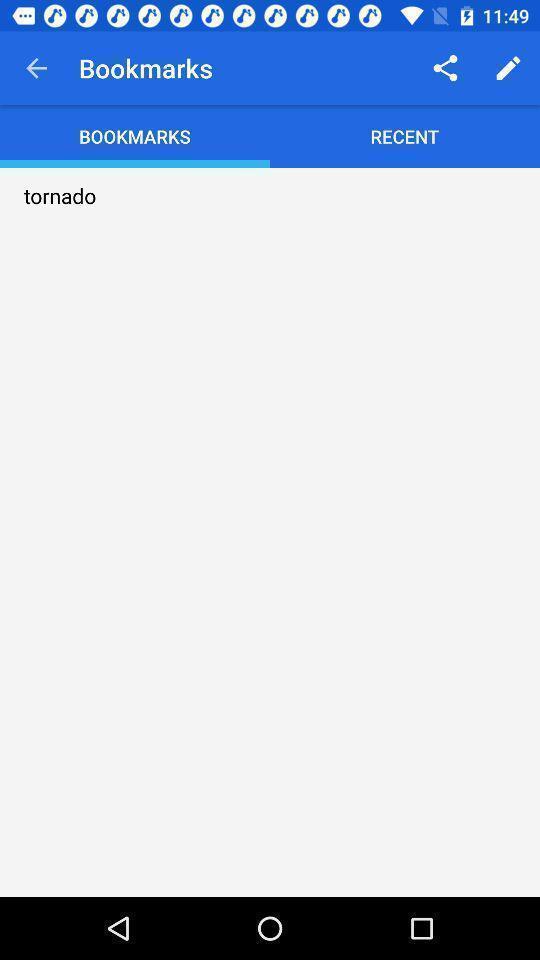Give me a summary of this screen capture. Screen page of a bookmarks. 